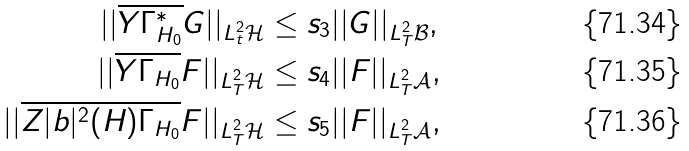<formula> <loc_0><loc_0><loc_500><loc_500>| | \overline { Y \Gamma _ { H _ { 0 } } ^ { * } } G | | _ { L ^ { 2 } _ { t } \mathcal { H } } & \leq s _ { 3 } | | G | | _ { L ^ { 2 } _ { T } { \mathcal { B } } } , \\ | | \overline { Y \Gamma _ { H _ { 0 } } } F | | _ { L ^ { 2 } _ { T } \mathcal { H } } & \leq s _ { 4 } | | F | | _ { L ^ { 2 } _ { T } { \mathcal { A } } } , \\ | | \overline { Z | b | ^ { 2 } ( H ) \Gamma _ { H _ { 0 } } } F | | _ { L ^ { 2 } _ { T } \mathcal { H } } & \leq s _ { 5 } | | F | | _ { L ^ { 2 } _ { T } { \mathcal { A } } } ,</formula> 